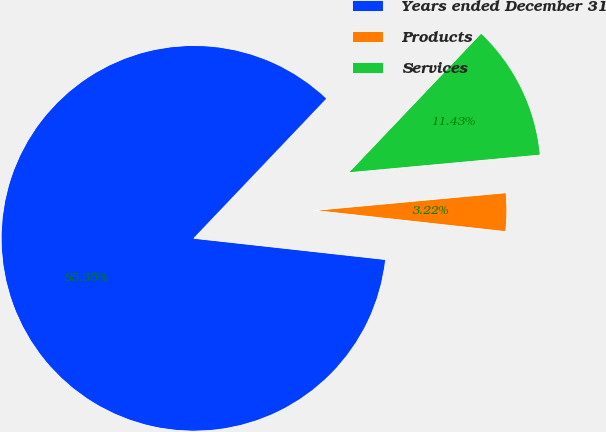<chart> <loc_0><loc_0><loc_500><loc_500><pie_chart><fcel>Years ended December 31<fcel>Products<fcel>Services<nl><fcel>85.35%<fcel>3.22%<fcel>11.43%<nl></chart> 